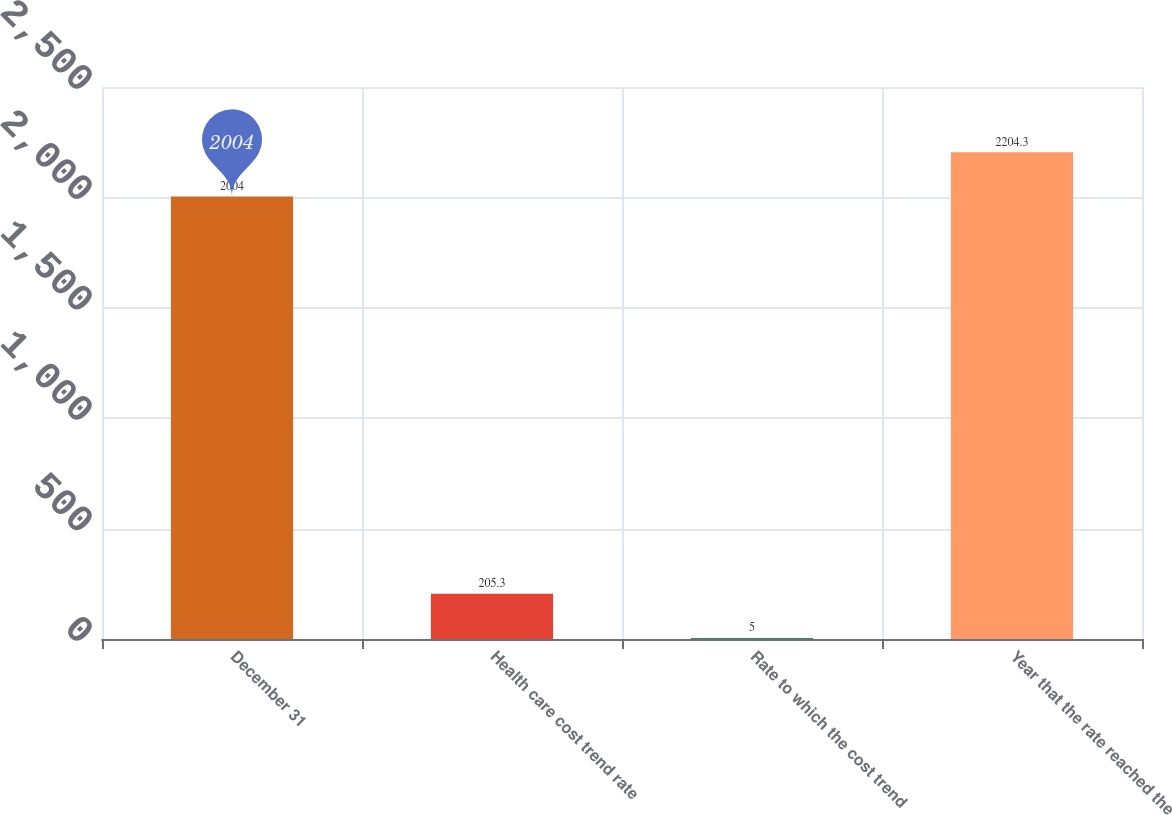<chart> <loc_0><loc_0><loc_500><loc_500><bar_chart><fcel>December 31<fcel>Health care cost trend rate<fcel>Rate to which the cost trend<fcel>Year that the rate reached the<nl><fcel>2004<fcel>205.3<fcel>5<fcel>2204.3<nl></chart> 